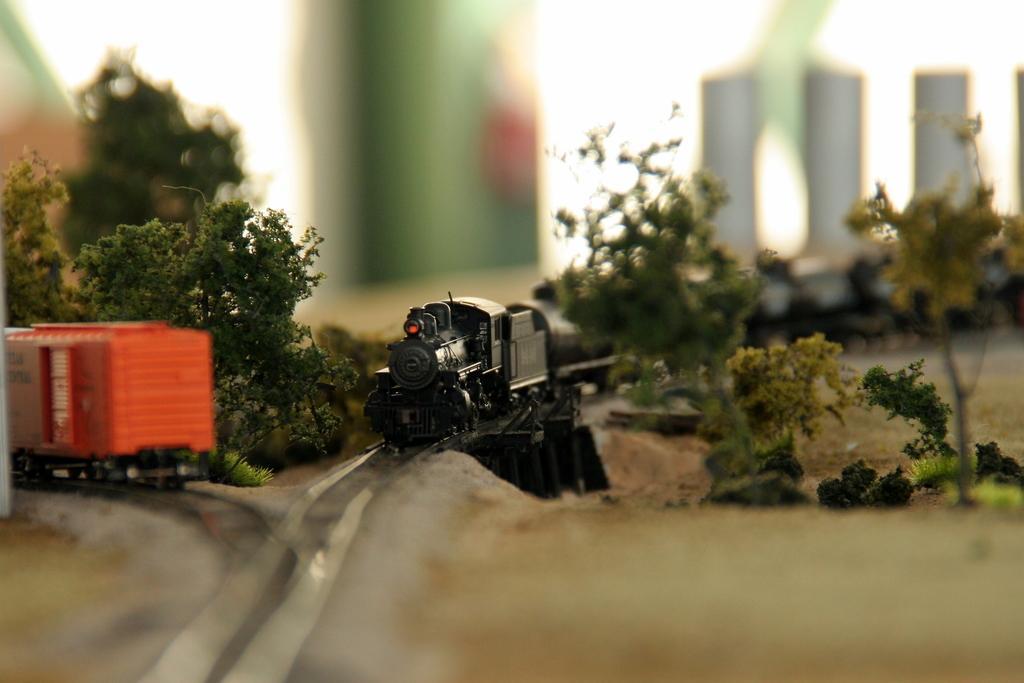Describe this image in one or two sentences. In this picture I can see toy trains on the toy railway tracks, there are trees, and there is blur background. 